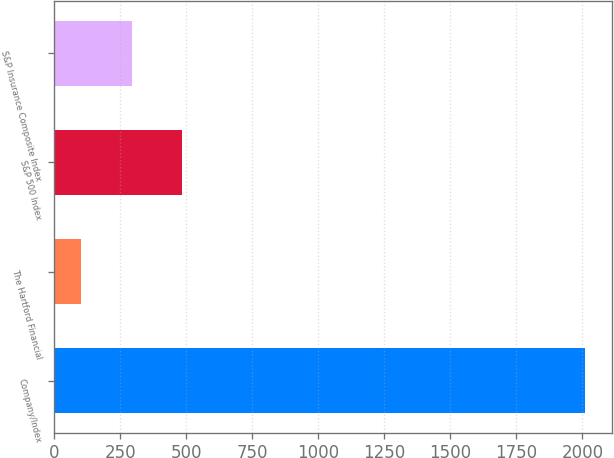Convert chart. <chart><loc_0><loc_0><loc_500><loc_500><bar_chart><fcel>Company/Index<fcel>The Hartford Financial<fcel>S&P 500 Index<fcel>S&P Insurance Composite Index<nl><fcel>2012<fcel>101.18<fcel>483.34<fcel>292.26<nl></chart> 